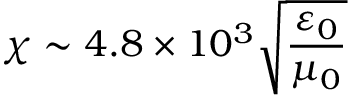<formula> <loc_0><loc_0><loc_500><loc_500>\chi \sim 4 . 8 \times 1 0 ^ { 3 } \sqrt { \frac { \varepsilon _ { 0 } } { \mu _ { 0 } } }</formula> 